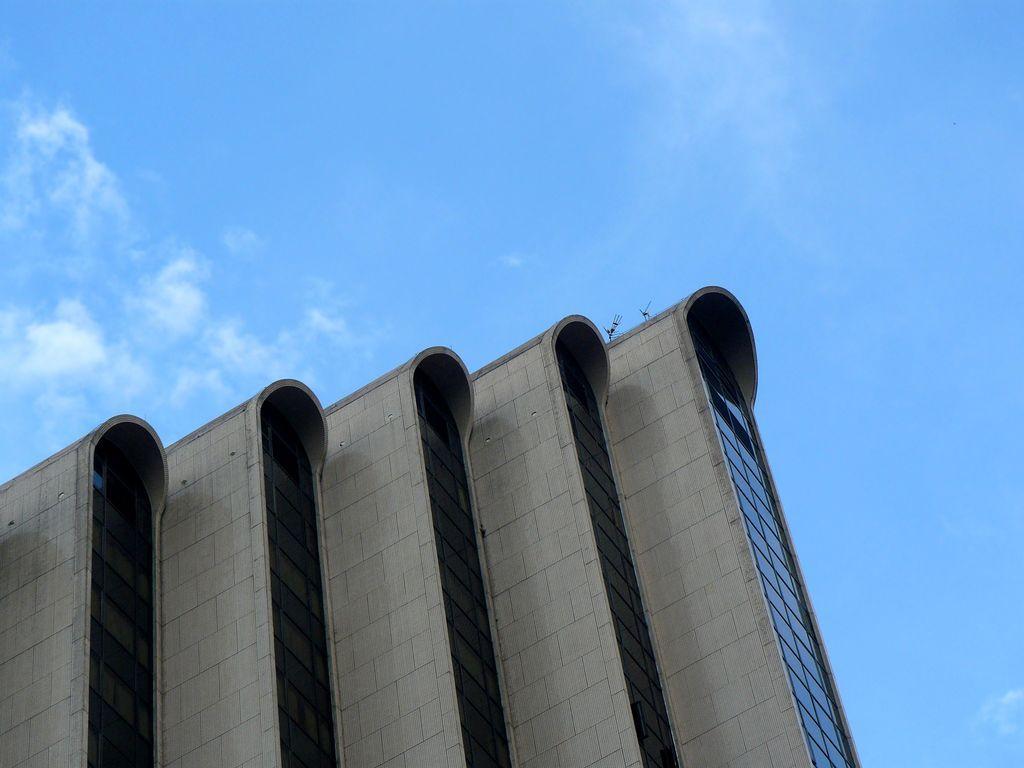Can you describe this image briefly? At the bottom of this image there is a building and I can see the glass windows. At the top of the image I can see the sky and clouds. 